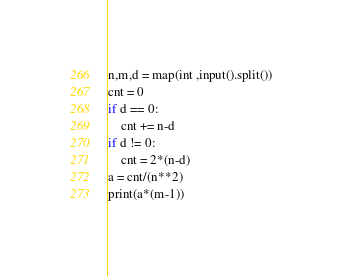<code> <loc_0><loc_0><loc_500><loc_500><_Python_>n,m,d = map(int ,input().split()) 
cnt = 0
if d == 0:
    cnt += n-d
if d != 0:
    cnt = 2*(n-d)
a = cnt/(n**2)
print(a*(m-1))</code> 